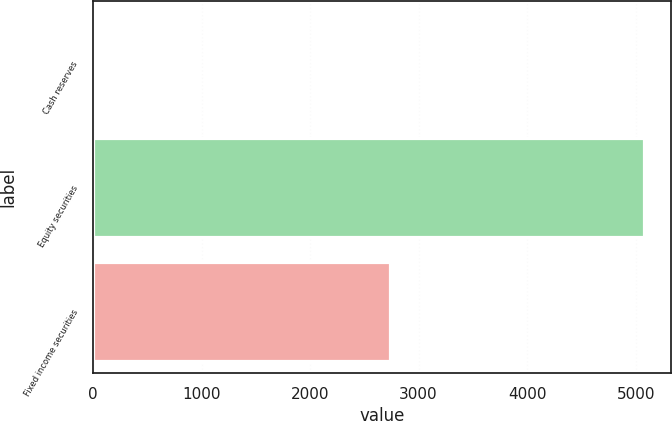<chart> <loc_0><loc_0><loc_500><loc_500><bar_chart><fcel>Cash reserves<fcel>Equity securities<fcel>Fixed income securities<nl><fcel>15<fcel>5076<fcel>2739<nl></chart> 